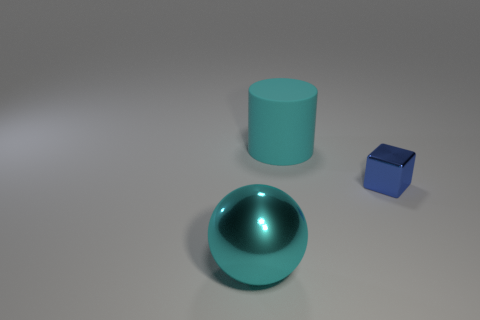There is a thing that is the same color as the big matte cylinder; what is its size?
Provide a succinct answer. Large. There is a large thing that is the same color as the metallic sphere; what is its material?
Give a very brief answer. Rubber. Are there any metal objects that have the same color as the big matte thing?
Offer a terse response. Yes. Is the big metal object the same color as the cylinder?
Provide a succinct answer. Yes. How many things are either small cyan metal things or things that are behind the metal sphere?
Offer a terse response. 2. How many cyan matte objects are on the left side of the cyan object that is behind the thing on the left side of the large matte thing?
Your response must be concise. 0. There is a tiny object that is made of the same material as the sphere; what color is it?
Ensure brevity in your answer.  Blue. Do the cyan object that is in front of the blue cube and the large rubber cylinder have the same size?
Make the answer very short. Yes. What number of objects are large cyan matte cylinders or cyan balls?
Ensure brevity in your answer.  2. What is the material of the thing that is in front of the tiny block that is on the right side of the large object to the right of the cyan shiny thing?
Offer a terse response. Metal. 